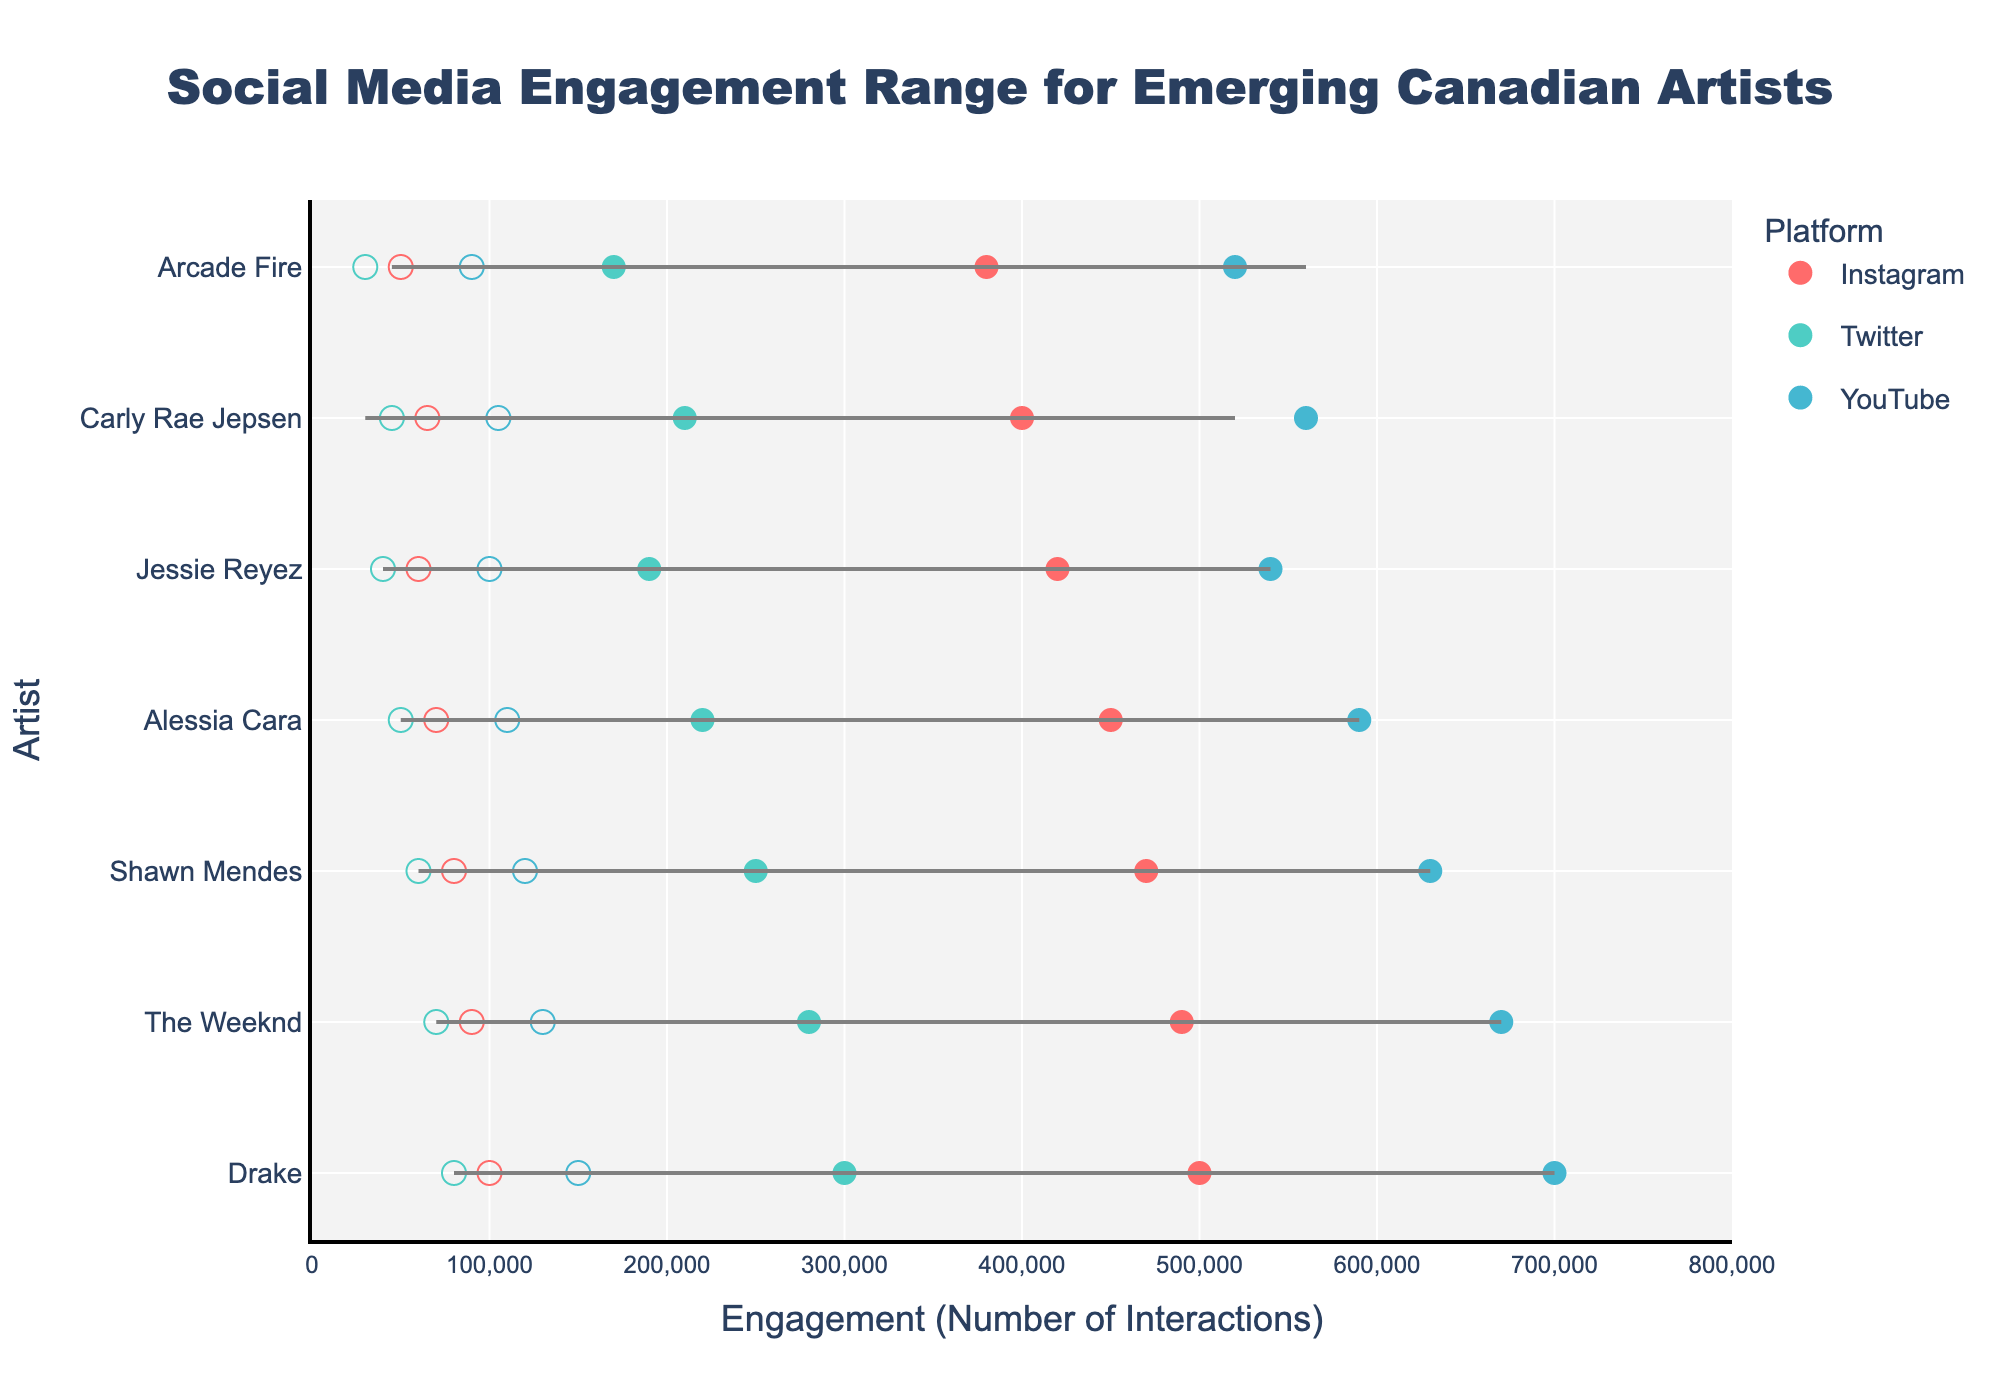What's the title of the figure? The title is usually displayed prominently at the top of the chart. It summarizes the main content and context of the figure. Here, it indicates that the figure is about social media engagement ranges for emerging Canadian artists, broken down by platform.
Answer: Social Media Engagement Range for Emerging Canadian Artists Which artist has the highest maximum engagement on YouTube? To find this, locate the maximum engagement values for YouTube across all artists. The highest value is 700,000, which corresponds to the artist Drake.
Answer: Drake What is the range of engagement for The Weeknd on Instagram? The range can be determined by subtracting the minimum engagement from the maximum engagement for The Weeknd on Instagram. The values provided are 90,000 (min) and 490,000 (max), so the range is 490,000 - 90,000.
Answer: 400,000 Which platform generally shows the highest engagement ranges for most artists? Compare the length of the ranges (difference between max and min engagements) across the platforms for each artist. You'll observe that YouTube typically has the largest range.
Answer: YouTube For Shawn Mendes, which platform shows the smallest engagement range? Identify Shawn Mendes' engagement ranges on each platform (Instagram, Twitter, YouTube). YouTube: 120,000 to 630,000 (510,000), Instagram: 80,000 to 470,000 (390,000), Twitter: 60,000 to 250,000 (190,000). Twitter has the smallest range.
Answer: Twitter How does Drake’s minimum engagement on Twitter compare to Jessie Reyez's maximum engagement on Twitter? Compare the given values directly. Drake's minimum engagement on Twitter is 80,000, whereas Jessie Reyez's maximum engagement on Twitter is 190,000. 80,000 is less than 190,000.
Answer: Less than Which artist has the narrowest engagement range on Instagram? Look at the engagement ranges (difference between min and max) on Instagram for all artists. Arcade Fire has the range of 50,000 to 380,000, which is 330,000. It's the narrowest compared to other artists.
Answer: Arcade Fire What is the difference in maximum YouTube engagement between Drake and Carly Rae Jepsen? Find the maximum engagement for both artists on YouTube: Drake has 700,000, and Carly Rae Jepsen has 560,000. The difference is calculated by 700,000 - 560,000.
Answer: 140,000 Which artist has the highest minimum engagement on any platform? Among all the platforms and artists, Drake's minimum engagement on YouTube is the highest at 150,000.
Answer: Drake How does Alessia Cara's engagement on Instagram compare with Carly Rae Jepsen's engagement on YouTube? Compare the engagement ranges of Alessia Cara on Instagram (70,000 to 450,000) to Carly Rae Jepsen on YouTube (105,000 to 560,000). Carly Rae Jepsen's engagement range on YouTube is generally higher.
Answer: Carly Rae Jepsen's YouTube engagement is higher 